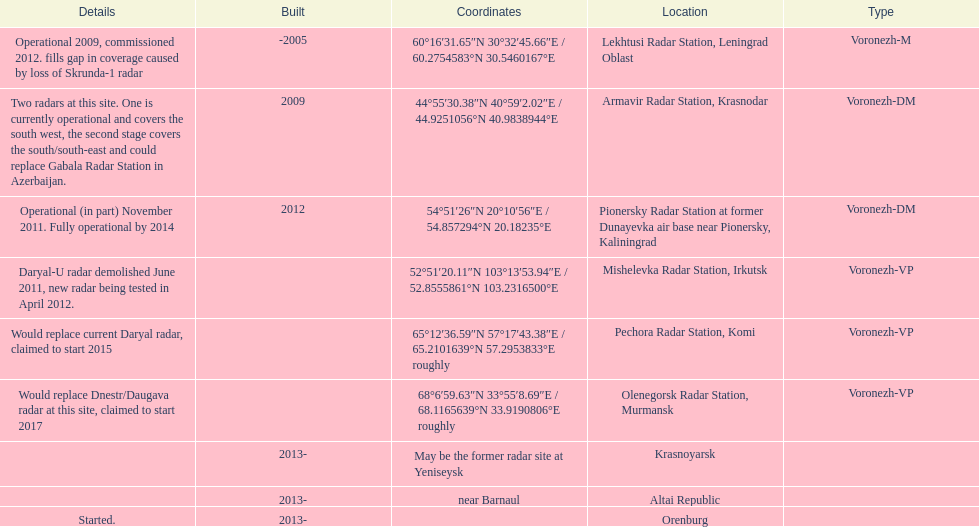What is the only radar that will start in 2015? Pechora Radar Station, Komi. 